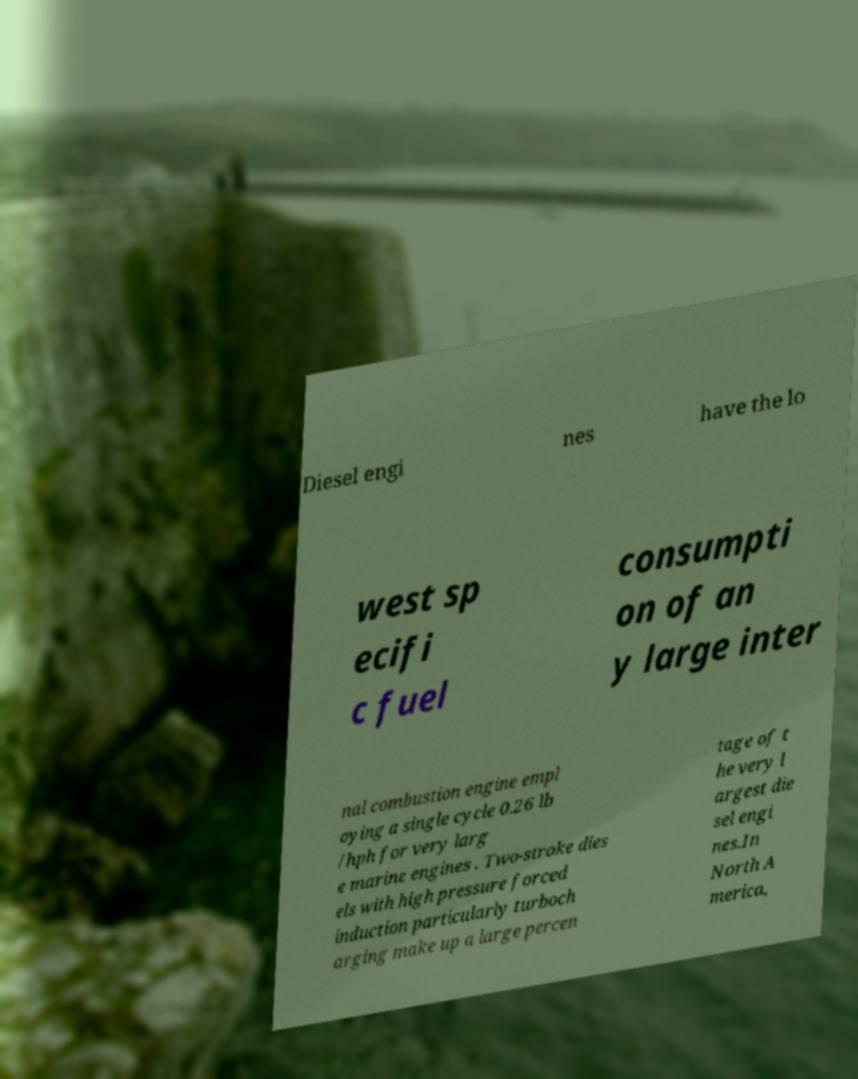Can you read and provide the text displayed in the image?This photo seems to have some interesting text. Can you extract and type it out for me? Diesel engi nes have the lo west sp ecifi c fuel consumpti on of an y large inter nal combustion engine empl oying a single cycle 0.26 lb /hph for very larg e marine engines . Two-stroke dies els with high pressure forced induction particularly turboch arging make up a large percen tage of t he very l argest die sel engi nes.In North A merica, 